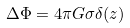Convert formula to latex. <formula><loc_0><loc_0><loc_500><loc_500>\Delta \Phi = 4 \pi G \sigma \delta ( z )</formula> 